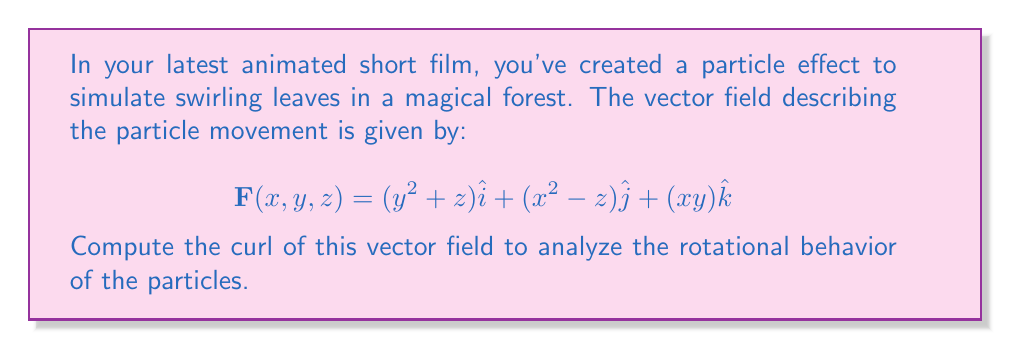Help me with this question. To compute the curl of the vector field, we'll use the formula:

$$\text{curl }\mathbf{F} = \nabla \times \mathbf{F} = \left(\frac{\partial F_z}{\partial y} - \frac{\partial F_y}{\partial z}\right)\hat{i} + \left(\frac{\partial F_x}{\partial z} - \frac{\partial F_z}{\partial x}\right)\hat{j} + \left(\frac{\partial F_y}{\partial x} - \frac{\partial F_x}{\partial y}\right)\hat{k}$$

Let's break it down step-by-step:

1. Identify the components of $\mathbf{F}$:
   $F_x = y^2 + z$
   $F_y = x^2 - z$
   $F_z = xy$

2. Calculate the partial derivatives:
   $\frac{\partial F_z}{\partial y} = x$
   $\frac{\partial F_y}{\partial z} = -1$
   $\frac{\partial F_x}{\partial z} = 1$
   $\frac{\partial F_z}{\partial x} = y$
   $\frac{\partial F_y}{\partial x} = 2x$
   $\frac{\partial F_x}{\partial y} = 2y$

3. Substitute into the curl formula:
   $\text{curl }\mathbf{F} = (x - (-1))\hat{i} + (1 - y)\hat{j} + (2x - 2y)\hat{k}$

4. Simplify:
   $\text{curl }\mathbf{F} = (x + 1)\hat{i} + (1 - y)\hat{j} + 2(x - y)\hat{k}$

This curl vector field describes the rotational behavior of the particle effect in your animated short film.
Answer: $$(x + 1)\hat{i} + (1 - y)\hat{j} + 2(x - y)\hat{k}$$ 